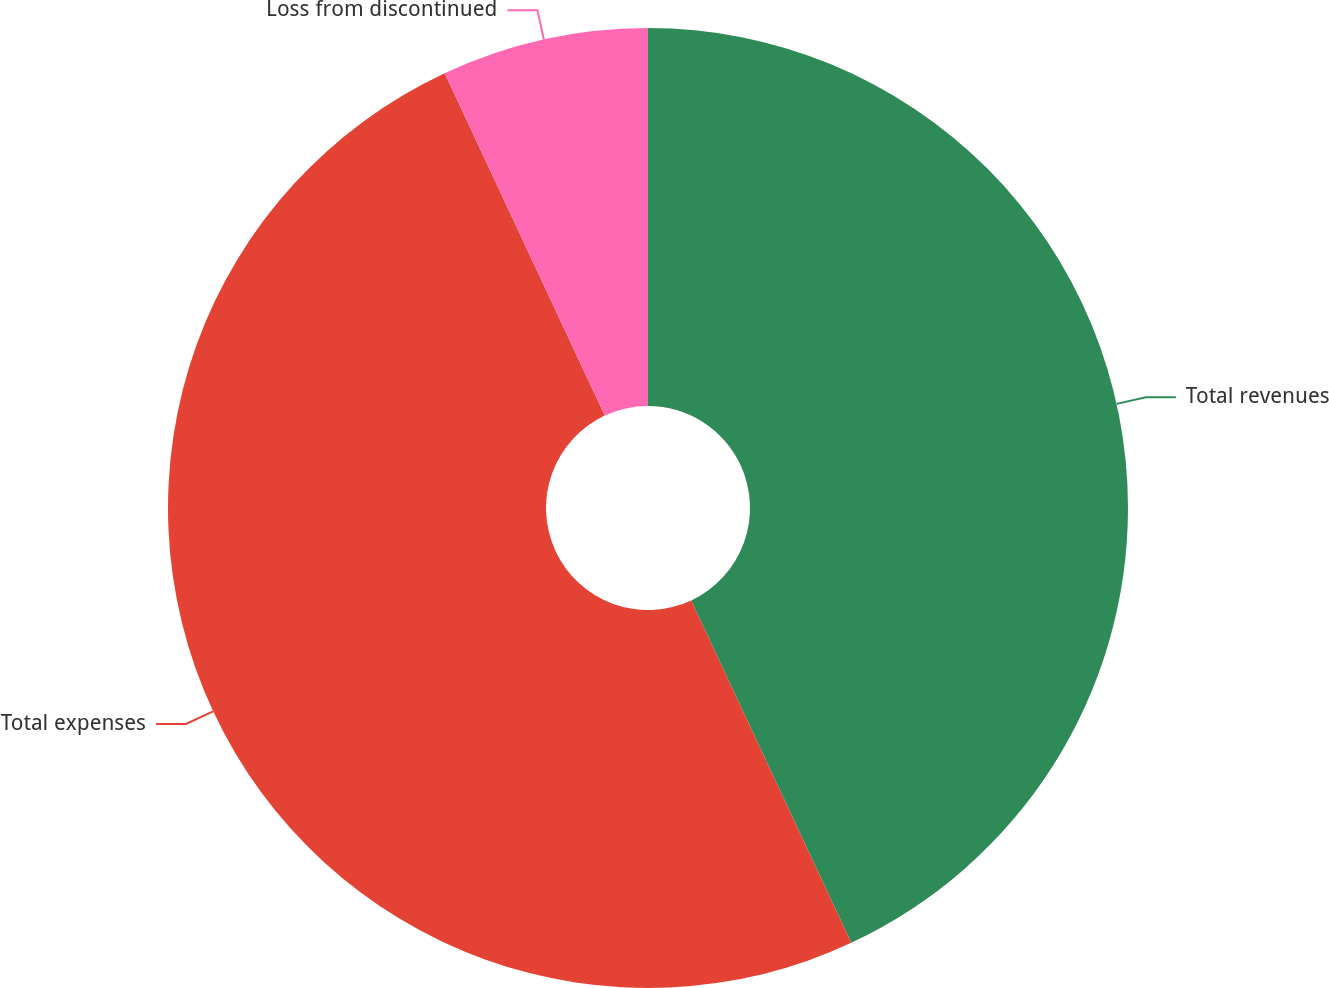Convert chart. <chart><loc_0><loc_0><loc_500><loc_500><pie_chart><fcel>Total revenues<fcel>Total expenses<fcel>Loss from discontinued<nl><fcel>43.04%<fcel>50.0%<fcel>6.96%<nl></chart> 